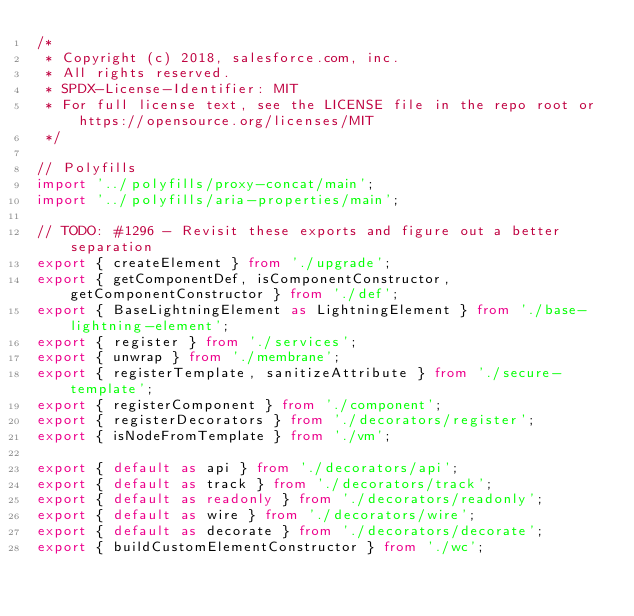Convert code to text. <code><loc_0><loc_0><loc_500><loc_500><_TypeScript_>/*
 * Copyright (c) 2018, salesforce.com, inc.
 * All rights reserved.
 * SPDX-License-Identifier: MIT
 * For full license text, see the LICENSE file in the repo root or https://opensource.org/licenses/MIT
 */

// Polyfills
import '../polyfills/proxy-concat/main';
import '../polyfills/aria-properties/main';

// TODO: #1296 - Revisit these exports and figure out a better separation
export { createElement } from './upgrade';
export { getComponentDef, isComponentConstructor, getComponentConstructor } from './def';
export { BaseLightningElement as LightningElement } from './base-lightning-element';
export { register } from './services';
export { unwrap } from './membrane';
export { registerTemplate, sanitizeAttribute } from './secure-template';
export { registerComponent } from './component';
export { registerDecorators } from './decorators/register';
export { isNodeFromTemplate } from './vm';

export { default as api } from './decorators/api';
export { default as track } from './decorators/track';
export { default as readonly } from './decorators/readonly';
export { default as wire } from './decorators/wire';
export { default as decorate } from './decorators/decorate';
export { buildCustomElementConstructor } from './wc';
</code> 